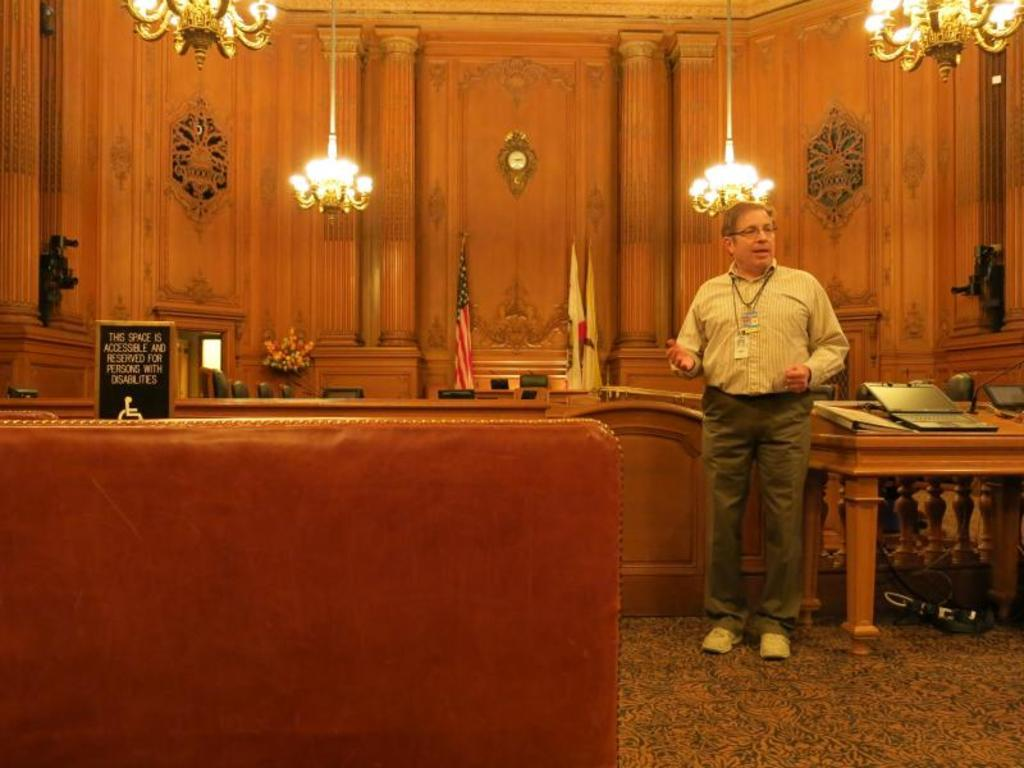What is the main subject of the image? There is a man standing in the image. Where is the man standing? The man is standing on the floor. What type of lighting is present in the image? There are chandeliers in the image. What piece of furniture can be seen in the image? There is a table in the image. What is on top of the table? There are objects on the table. What decorative elements are present in the image? There are flags and a flower pot in the image. How many babies are crawling under the table in the image? There are no babies present in the image, so it is not possible to determine how many might be crawling under the table. 